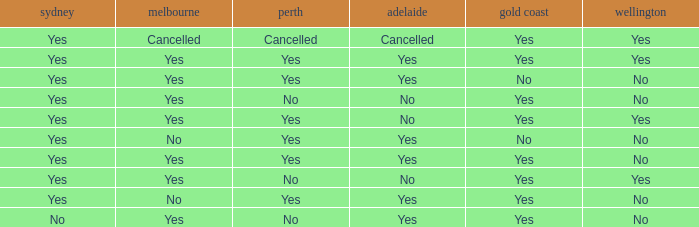What is the sydney that has adelaide, gold coast, melbourne, and auckland are all yes? Yes. 